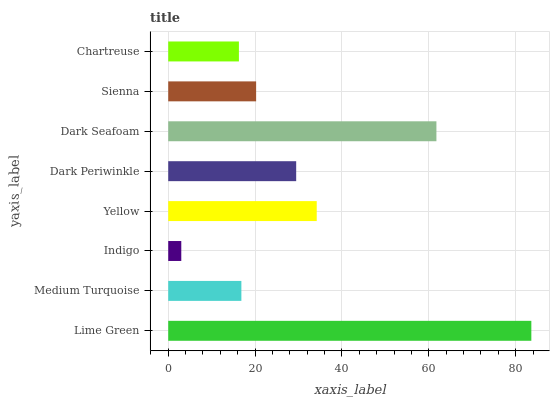Is Indigo the minimum?
Answer yes or no. Yes. Is Lime Green the maximum?
Answer yes or no. Yes. Is Medium Turquoise the minimum?
Answer yes or no. No. Is Medium Turquoise the maximum?
Answer yes or no. No. Is Lime Green greater than Medium Turquoise?
Answer yes or no. Yes. Is Medium Turquoise less than Lime Green?
Answer yes or no. Yes. Is Medium Turquoise greater than Lime Green?
Answer yes or no. No. Is Lime Green less than Medium Turquoise?
Answer yes or no. No. Is Dark Periwinkle the high median?
Answer yes or no. Yes. Is Sienna the low median?
Answer yes or no. Yes. Is Lime Green the high median?
Answer yes or no. No. Is Indigo the low median?
Answer yes or no. No. 